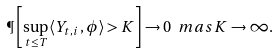Convert formula to latex. <formula><loc_0><loc_0><loc_500><loc_500>\P \left [ \sup _ { t \leq T } \langle Y _ { t , i } \, , \phi \rangle > K \right ] \to 0 \ m a s K \to \infty .</formula> 